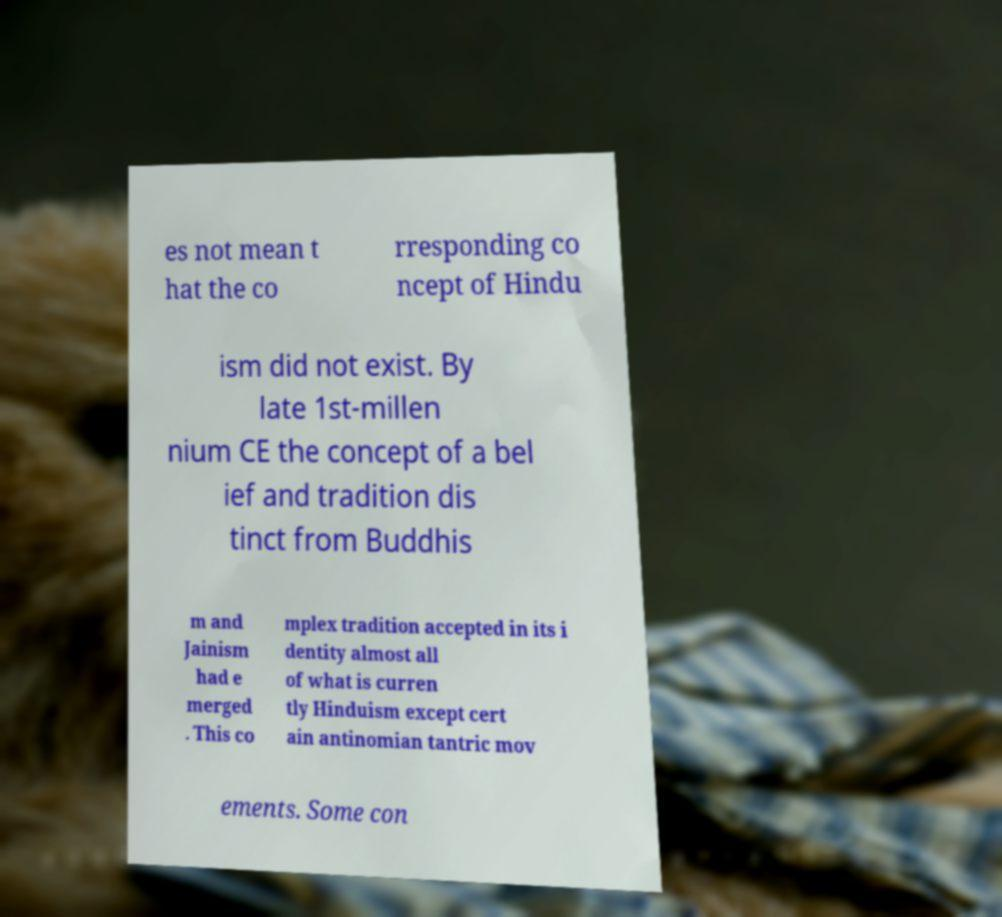For documentation purposes, I need the text within this image transcribed. Could you provide that? es not mean t hat the co rresponding co ncept of Hindu ism did not exist. By late 1st-millen nium CE the concept of a bel ief and tradition dis tinct from Buddhis m and Jainism had e merged . This co mplex tradition accepted in its i dentity almost all of what is curren tly Hinduism except cert ain antinomian tantric mov ements. Some con 